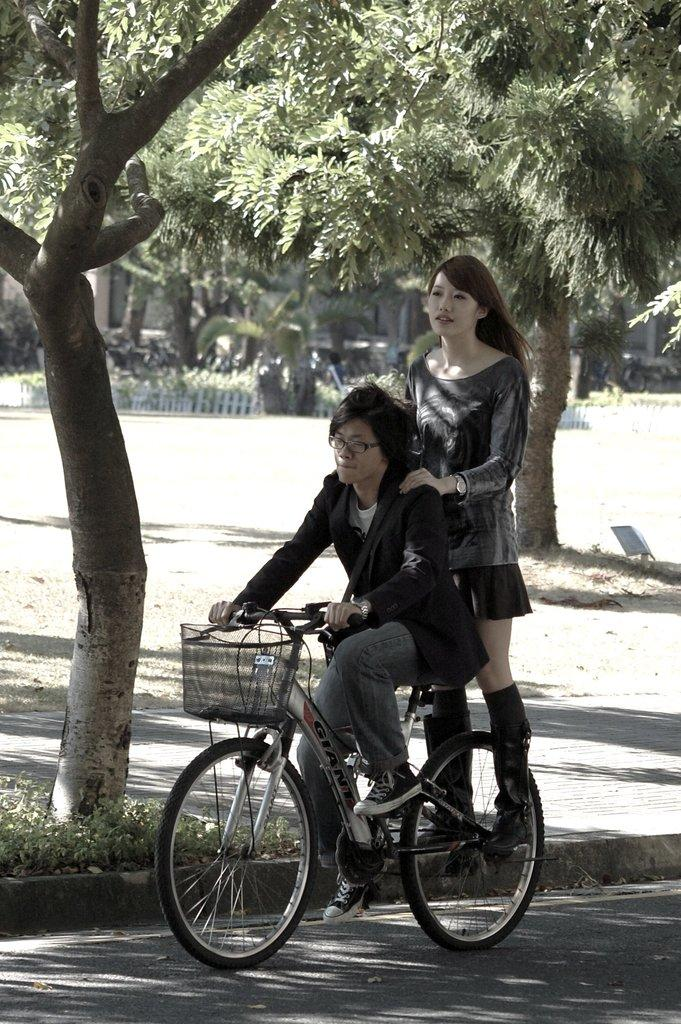How many people are in the image? There are two persons in the image. What is the man doing in the image? The man is riding a bicycle. What is the woman doing in the image? The woman is standing on the bicycle. What can be seen in the background of the image? There are trees and a garden in the background of the image. What type of instrument is the woman playing while standing on the bicycle? There is no instrument present in the image; the woman is simply standing on the bicycle. 